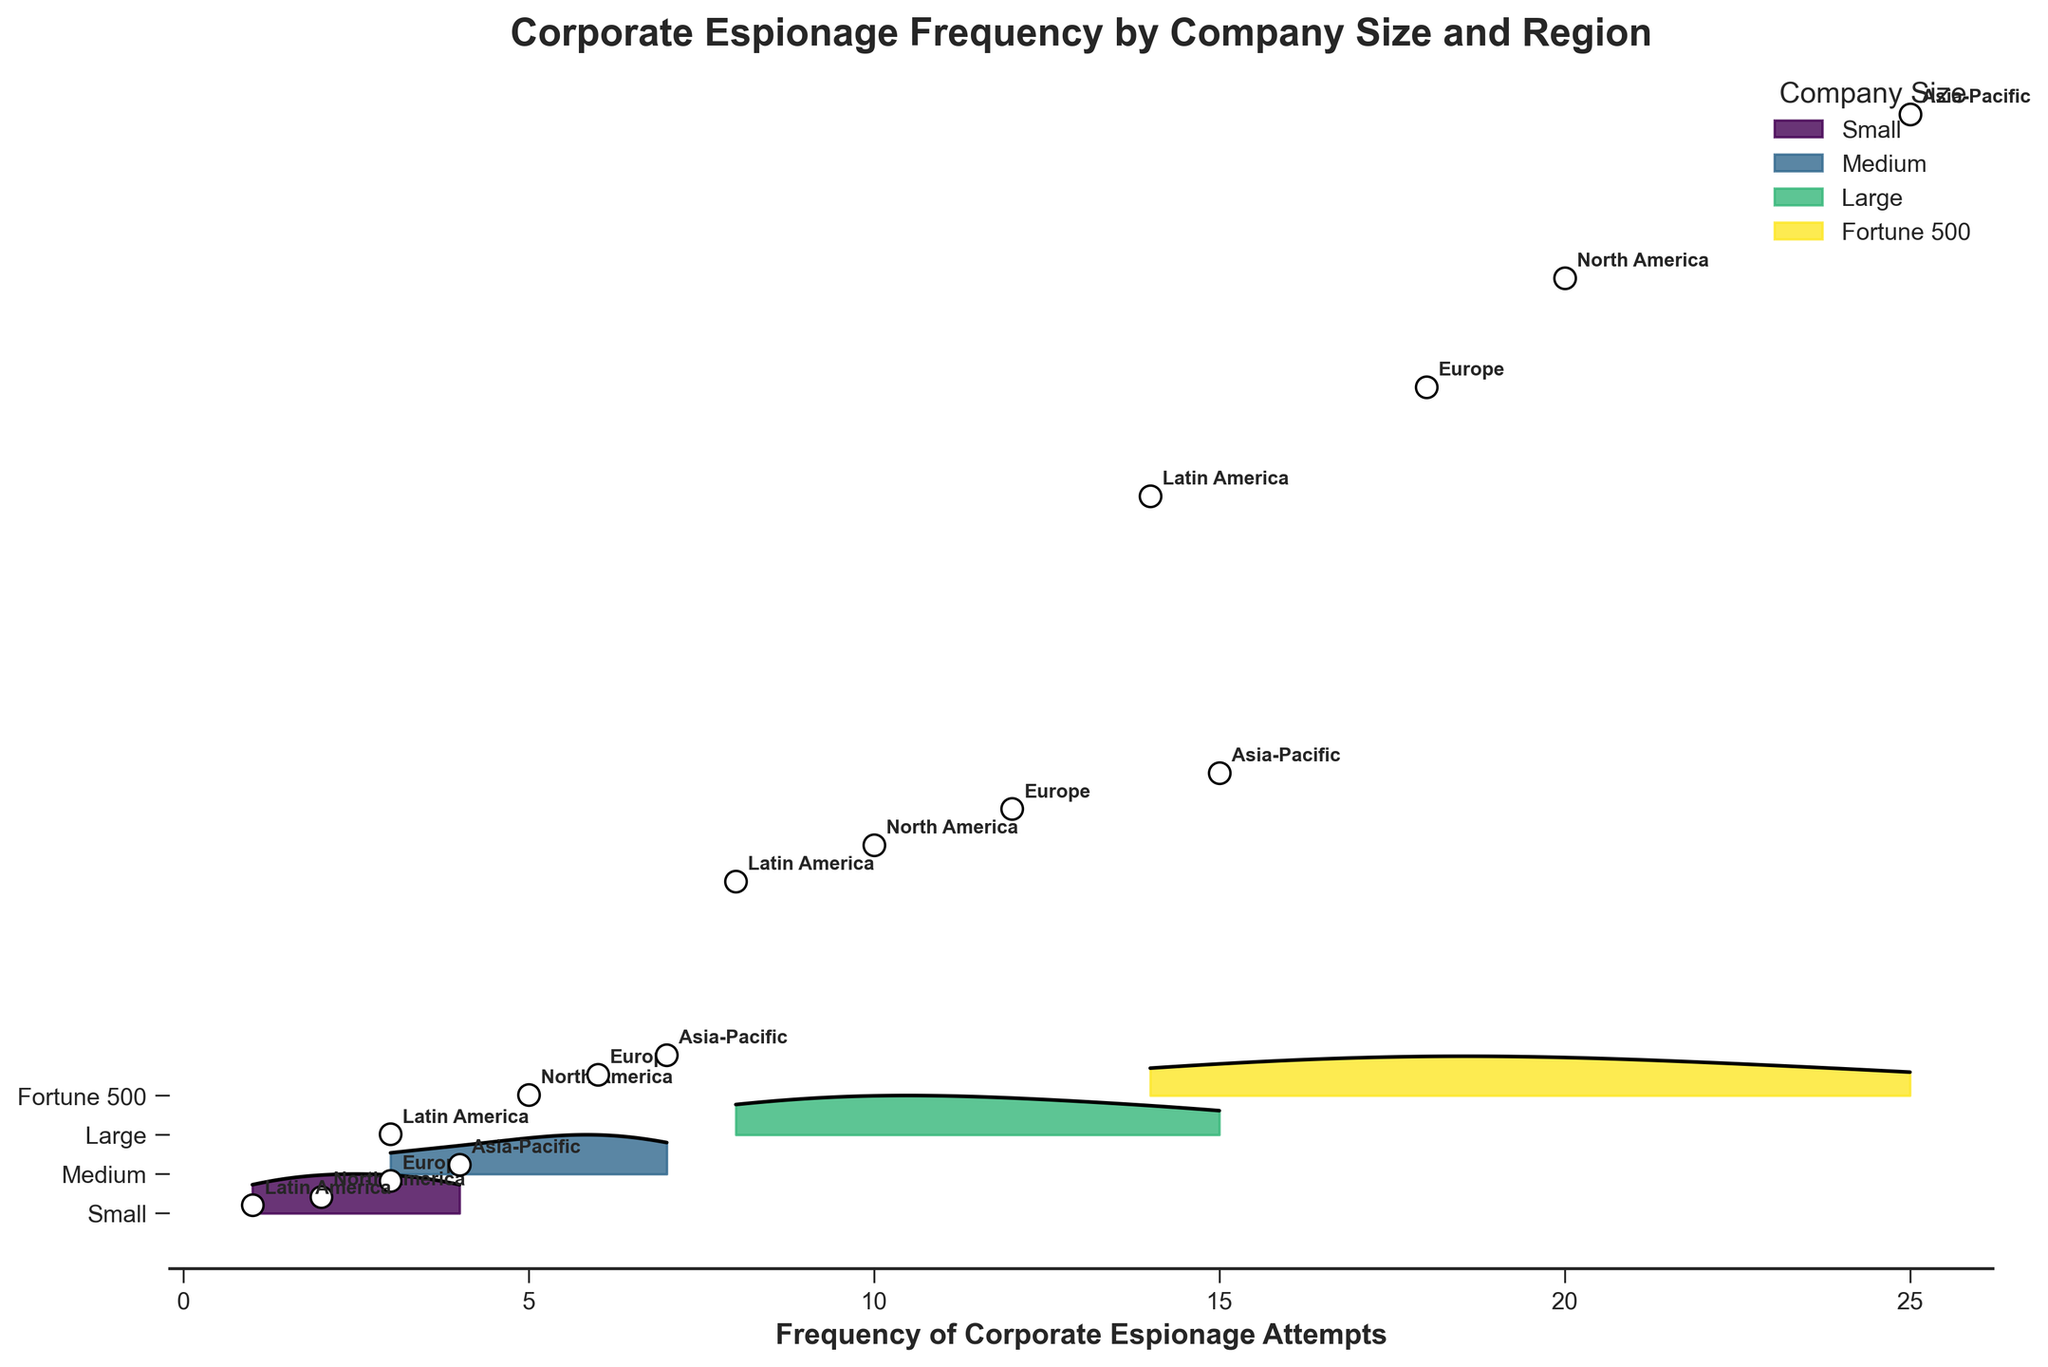What is the title of the plot? The title of the plot is usually located at the top of the figure. It gives a brief description of what the plot represents. In this case, the title is clearly written as "Corporate Espionage Frequency by Company Size and Region".
Answer: Corporate Espionage Frequency by Company Size and Region Which company size category experiences the highest frequency of corporate espionage attempts in Asia-Pacific? To determine this, locate the company size categories on the y-axis and find the associated frequencies on the x-axis for the Asia-Pacific region. The largest frequency in Asia-Pacific is associated with the Fortune 500 companies, with a frequency of 25.
Answer: Fortune 500 Which region has the lowest density of corporate espionage attempts for small-sized companies? Look at the points labeled for each region along the ridgeline for small-sized companies. Compare the densities indicated by the height of the ridgeline or the annotated points. Latin America has a density of 0.05, which is the lowest.
Answer: Latin America Compare the frequency of corporate espionage attempts between medium-sized companies in North America and Europe. Which is higher? Locate the ridgeline curves for medium-sized companies and compare the frequency points labeled "North America" and "Europe". North America has a frequency of 5, while Europe has a frequency of 6. Europe is higher.
Answer: Europe What is the average frequency of corporate espionage attempts for large-sized companies? To find the average, sum the frequencies for the large-sized companies and divide by the number of regions. The frequencies are 10 (North America), 12 (Europe), 15 (Asia-Pacific), and 8 (Latin America). Sum = 10 + 12 + 15 + 8 = 45. Divide by 4: 45/4 = 11.25.
Answer: 11.25 Which company size has the lowest overall density of corporate espionage attempts? Compare the overall densities for each company size category as represented by the height of the ridgeline plots. The ridgeline for small-sized companies is the lowest compared to others.
Answer: Small How does the frequency of corporate espionage attempts in North America compare between small and Fortune 500 companies? Identify the frequency points for North America under both small-sized and Fortune 500 categories. Small companies have a frequency of 2 and Fortune 500 companies have a frequency of 20. The frequency for Fortune 500 is much higher.
Answer: Fortune 500 is much higher What is the range of frequencies for medium-sized companies? Identify the minimum and maximum frequencies for medium-sized companies. The frequencies are 5 (North America), 6 (Europe), 7 (Asia-Pacific), and 3 (Latin America). The range is the difference between the max and min values: 7 - 3 = 4.
Answer: 4 Which company size category shows the highest density in Europe? Locate the ridgeline plots for Europe and identify which company size category has the highest density based on the height of the ridgeline or annotations. Fortune 500 companies have the highest density with a value of 1.3.
Answer: Fortune 500 